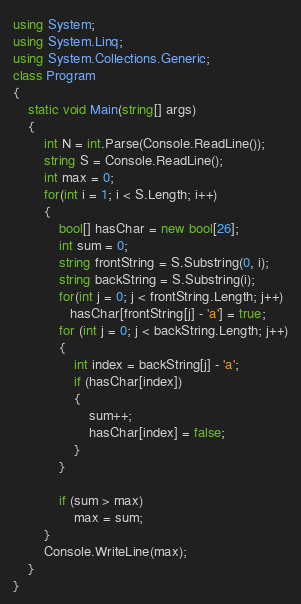Convert code to text. <code><loc_0><loc_0><loc_500><loc_500><_C#_>using System;
using System.Linq;
using System.Collections.Generic;
class Program
{
    static void Main(string[] args)
    {
        int N = int.Parse(Console.ReadLine());
        string S = Console.ReadLine();
        int max = 0;
        for(int i = 1; i < S.Length; i++)
        {
            bool[] hasChar = new bool[26];
            int sum = 0;
            string frontString = S.Substring(0, i);
            string backString = S.Substring(i);
            for(int j = 0; j < frontString.Length; j++)
               hasChar[frontString[j] - 'a'] = true;
            for (int j = 0; j < backString.Length; j++)
            {
                int index = backString[j] - 'a';
                if (hasChar[index])
                {
                    sum++;
                    hasChar[index] = false;
                }
            }

            if (sum > max)
                max = sum;
        }
        Console.WriteLine(max);
    }
}
</code> 